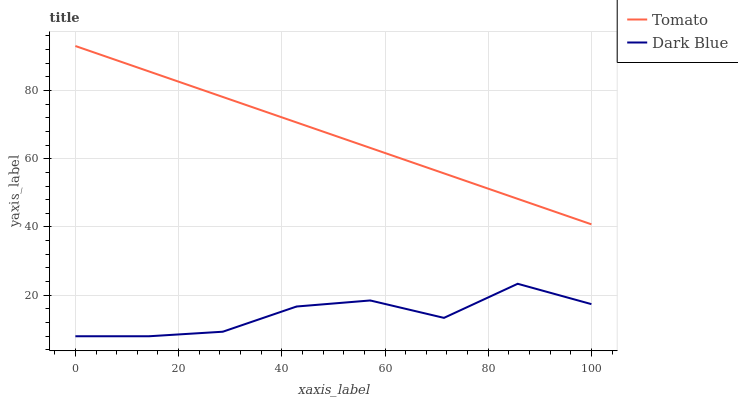Does Dark Blue have the minimum area under the curve?
Answer yes or no. Yes. Does Tomato have the maximum area under the curve?
Answer yes or no. Yes. Does Dark Blue have the maximum area under the curve?
Answer yes or no. No. Is Tomato the smoothest?
Answer yes or no. Yes. Is Dark Blue the roughest?
Answer yes or no. Yes. Is Dark Blue the smoothest?
Answer yes or no. No. Does Dark Blue have the lowest value?
Answer yes or no. Yes. Does Tomato have the highest value?
Answer yes or no. Yes. Does Dark Blue have the highest value?
Answer yes or no. No. Is Dark Blue less than Tomato?
Answer yes or no. Yes. Is Tomato greater than Dark Blue?
Answer yes or no. Yes. Does Dark Blue intersect Tomato?
Answer yes or no. No. 